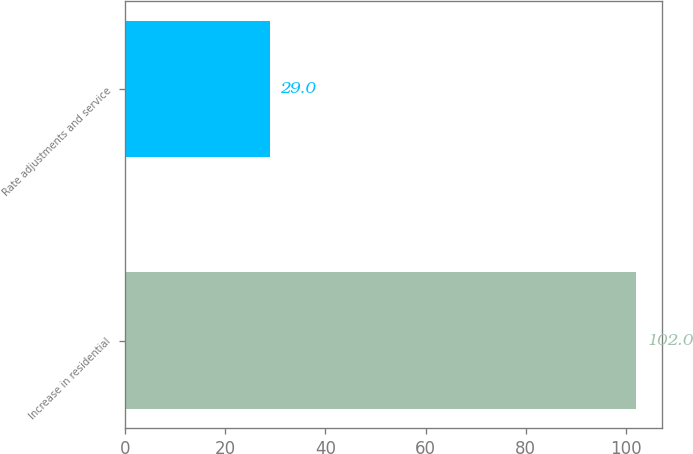Convert chart to OTSL. <chart><loc_0><loc_0><loc_500><loc_500><bar_chart><fcel>Increase in residential<fcel>Rate adjustments and service<nl><fcel>102<fcel>29<nl></chart> 